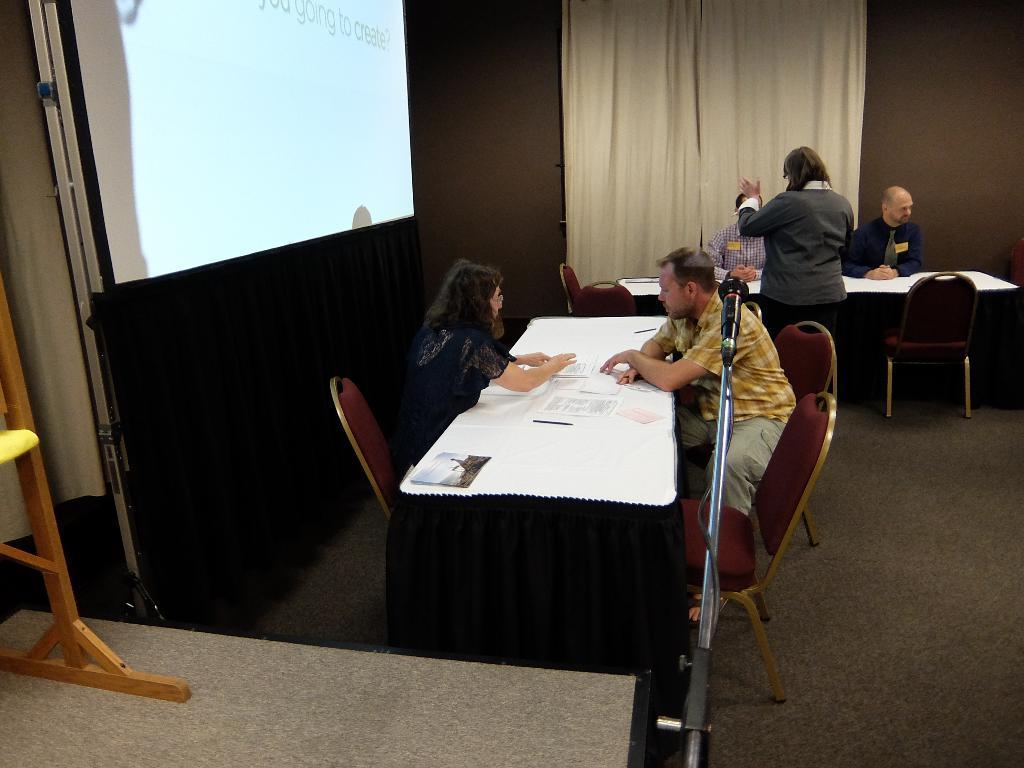In one or two sentences, can you explain what this image depicts? This picture shows couple of people seated on the chairs and a woman standing we see few papers on the table and we see a projector screen on the left 